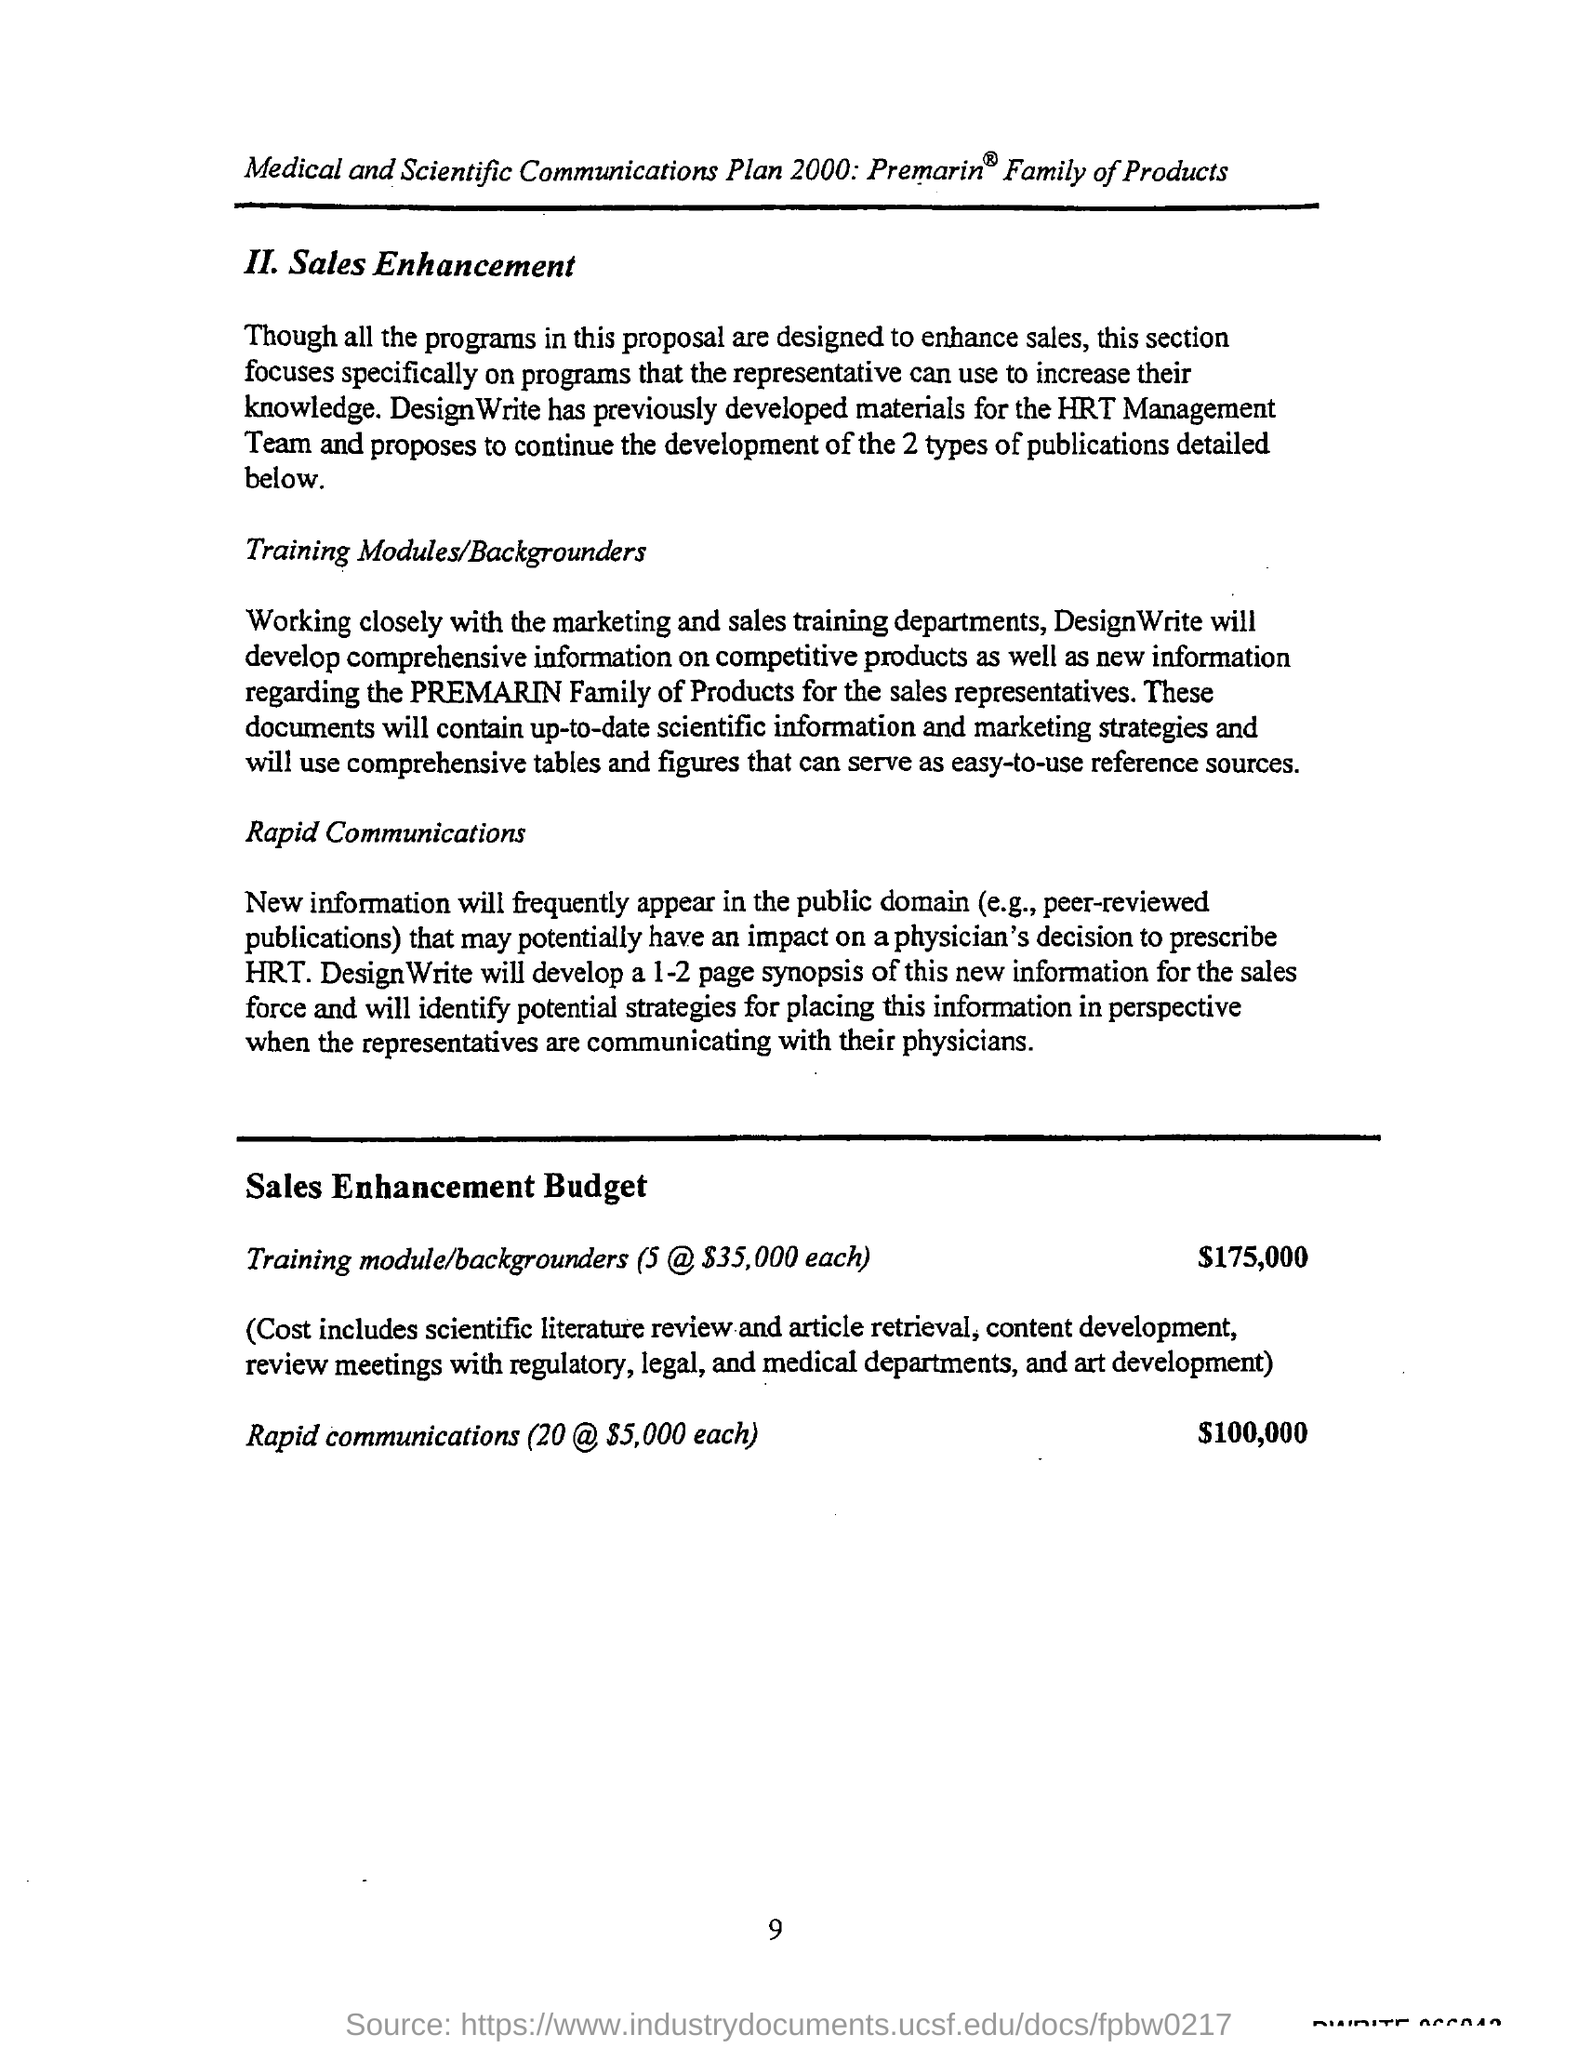Outline some significant characteristics in this image. The training module budget amount is $175,000. The main objective of this program design is to promote sales growth. 